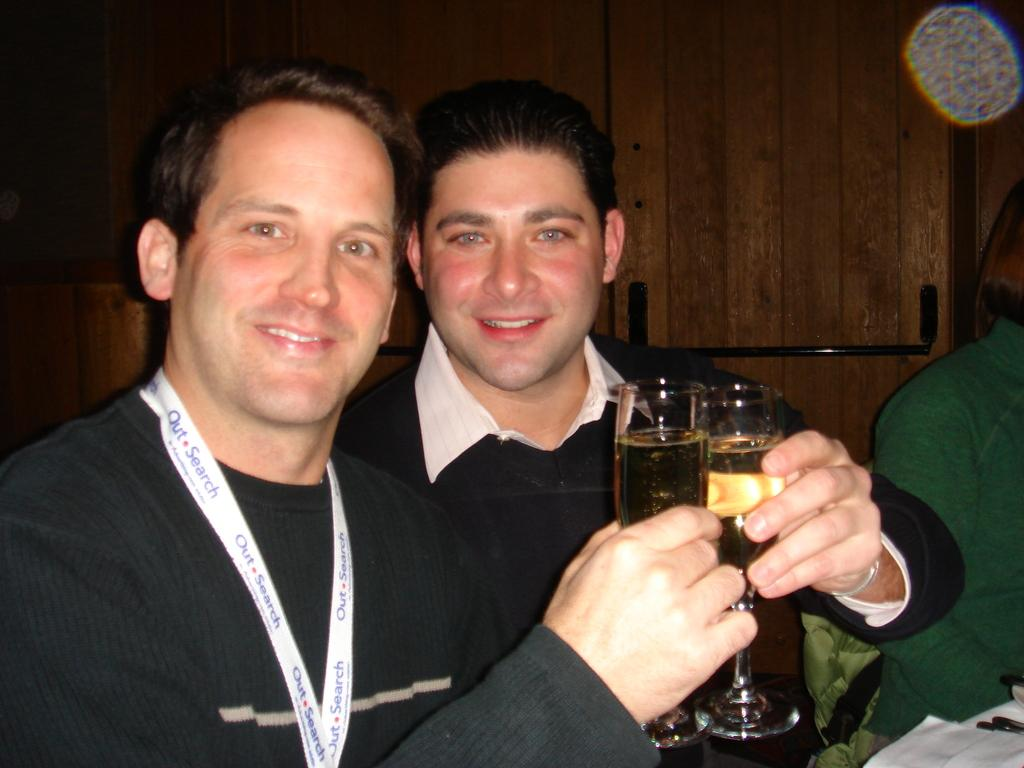How many people are in the image? There are two persons in the image. What are the persons holding in their hands? The persons are holding glasses with drinks in their hands. What can be seen in the background of the image? There is a wooden wall in the background of the image. What type of cracker is being used to frame the image? There is no cracker present in the image, nor is there any framing device mentioned. 